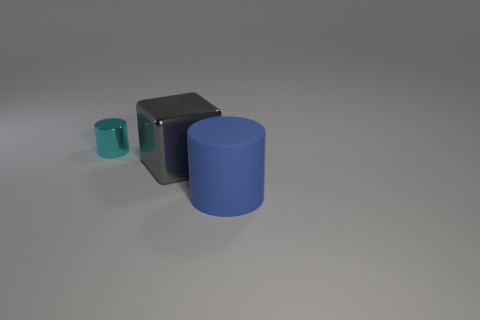What materials do the objects in the image seem to be made of? The objects in the image appear to be made of a smooth, matte material, possibly a type of plastic or metal with a non-reflective finish, judging by the way the light subtly accentuates their shapes without causing a significant shine. 